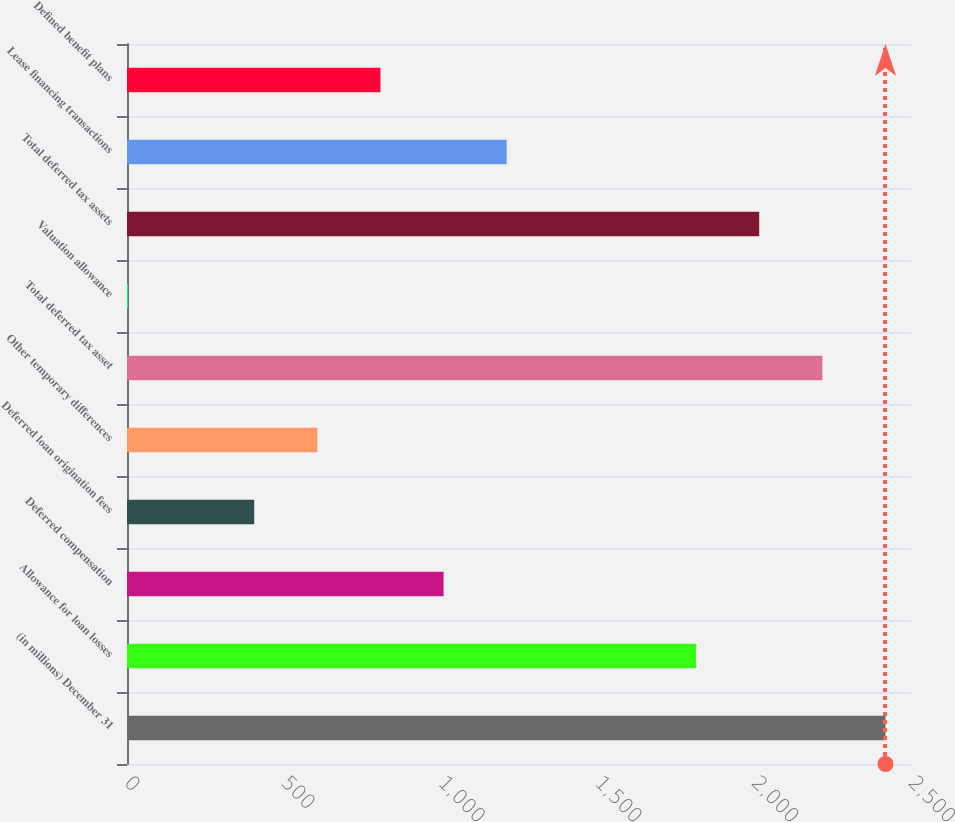Convert chart. <chart><loc_0><loc_0><loc_500><loc_500><bar_chart><fcel>(in millions) December 31<fcel>Allowance for loan losses<fcel>Deferred compensation<fcel>Deferred loan origination fees<fcel>Other temporary differences<fcel>Total deferred tax asset<fcel>Valuation allowance<fcel>Total deferred tax assets<fcel>Lease financing transactions<fcel>Defined benefit plans<nl><fcel>2418.6<fcel>1814.7<fcel>1009.5<fcel>405.6<fcel>606.9<fcel>2217.3<fcel>3<fcel>2016<fcel>1210.8<fcel>808.2<nl></chart> 